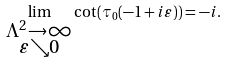<formula> <loc_0><loc_0><loc_500><loc_500>\lim _ { \substack { \Lambda ^ { 2 } \to \infty \\ \varepsilon \searrow 0 } } \cot ( \tau _ { 0 } ( - 1 + i \varepsilon ) ) = - i .</formula> 